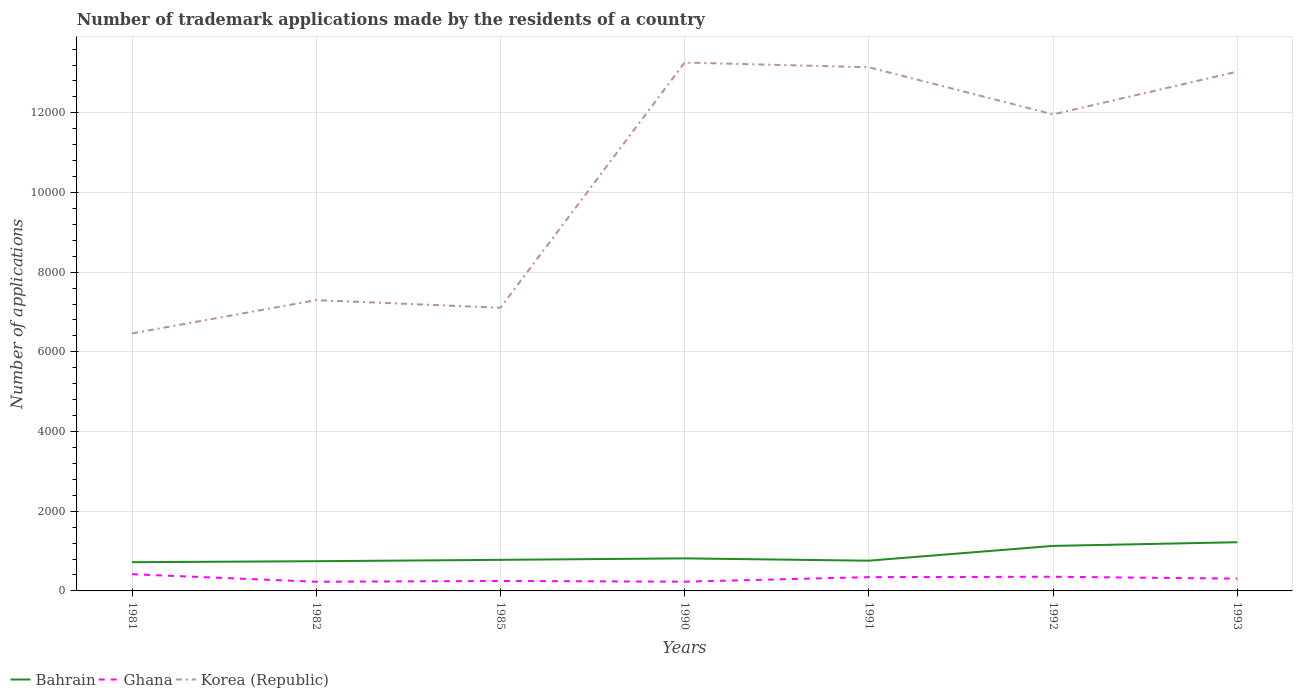Across all years, what is the maximum number of trademark applications made by the residents in Korea (Republic)?
Provide a succinct answer. 6463. In which year was the number of trademark applications made by the residents in Bahrain maximum?
Your answer should be very brief. 1981. What is the total number of trademark applications made by the residents in Bahrain in the graph?
Offer a very short reply. -384. What is the difference between the highest and the second highest number of trademark applications made by the residents in Ghana?
Your answer should be very brief. 189. What is the difference between the highest and the lowest number of trademark applications made by the residents in Ghana?
Your answer should be very brief. 4. Is the number of trademark applications made by the residents in Bahrain strictly greater than the number of trademark applications made by the residents in Ghana over the years?
Give a very brief answer. No. How many years are there in the graph?
Keep it short and to the point. 7. What is the difference between two consecutive major ticks on the Y-axis?
Provide a succinct answer. 2000. Are the values on the major ticks of Y-axis written in scientific E-notation?
Your answer should be very brief. No. How many legend labels are there?
Offer a terse response. 3. How are the legend labels stacked?
Your response must be concise. Horizontal. What is the title of the graph?
Offer a terse response. Number of trademark applications made by the residents of a country. What is the label or title of the Y-axis?
Keep it short and to the point. Number of applications. What is the Number of applications of Bahrain in 1981?
Give a very brief answer. 721. What is the Number of applications of Ghana in 1981?
Offer a very short reply. 419. What is the Number of applications in Korea (Republic) in 1981?
Keep it short and to the point. 6463. What is the Number of applications in Bahrain in 1982?
Your response must be concise. 746. What is the Number of applications of Ghana in 1982?
Make the answer very short. 230. What is the Number of applications of Korea (Republic) in 1982?
Give a very brief answer. 7299. What is the Number of applications of Bahrain in 1985?
Your answer should be very brief. 780. What is the Number of applications of Ghana in 1985?
Provide a short and direct response. 250. What is the Number of applications in Korea (Republic) in 1985?
Offer a terse response. 7107. What is the Number of applications in Bahrain in 1990?
Your answer should be compact. 817. What is the Number of applications of Ghana in 1990?
Your answer should be compact. 232. What is the Number of applications of Korea (Republic) in 1990?
Your answer should be compact. 1.33e+04. What is the Number of applications in Bahrain in 1991?
Your answer should be very brief. 759. What is the Number of applications in Ghana in 1991?
Offer a very short reply. 346. What is the Number of applications in Korea (Republic) in 1991?
Make the answer very short. 1.31e+04. What is the Number of applications in Bahrain in 1992?
Your answer should be very brief. 1130. What is the Number of applications of Ghana in 1992?
Your answer should be very brief. 356. What is the Number of applications in Korea (Republic) in 1992?
Keep it short and to the point. 1.20e+04. What is the Number of applications of Bahrain in 1993?
Keep it short and to the point. 1222. What is the Number of applications of Ghana in 1993?
Your answer should be very brief. 308. What is the Number of applications in Korea (Republic) in 1993?
Provide a succinct answer. 1.30e+04. Across all years, what is the maximum Number of applications in Bahrain?
Offer a very short reply. 1222. Across all years, what is the maximum Number of applications of Ghana?
Your answer should be compact. 419. Across all years, what is the maximum Number of applications in Korea (Republic)?
Your answer should be compact. 1.33e+04. Across all years, what is the minimum Number of applications of Bahrain?
Provide a short and direct response. 721. Across all years, what is the minimum Number of applications in Ghana?
Provide a succinct answer. 230. Across all years, what is the minimum Number of applications of Korea (Republic)?
Ensure brevity in your answer.  6463. What is the total Number of applications of Bahrain in the graph?
Offer a terse response. 6175. What is the total Number of applications of Ghana in the graph?
Keep it short and to the point. 2141. What is the total Number of applications in Korea (Republic) in the graph?
Ensure brevity in your answer.  7.23e+04. What is the difference between the Number of applications of Ghana in 1981 and that in 1982?
Give a very brief answer. 189. What is the difference between the Number of applications of Korea (Republic) in 1981 and that in 1982?
Offer a very short reply. -836. What is the difference between the Number of applications in Bahrain in 1981 and that in 1985?
Make the answer very short. -59. What is the difference between the Number of applications of Ghana in 1981 and that in 1985?
Provide a short and direct response. 169. What is the difference between the Number of applications of Korea (Republic) in 1981 and that in 1985?
Ensure brevity in your answer.  -644. What is the difference between the Number of applications of Bahrain in 1981 and that in 1990?
Keep it short and to the point. -96. What is the difference between the Number of applications in Ghana in 1981 and that in 1990?
Your answer should be compact. 187. What is the difference between the Number of applications of Korea (Republic) in 1981 and that in 1990?
Make the answer very short. -6799. What is the difference between the Number of applications of Bahrain in 1981 and that in 1991?
Offer a terse response. -38. What is the difference between the Number of applications in Ghana in 1981 and that in 1991?
Keep it short and to the point. 73. What is the difference between the Number of applications of Korea (Republic) in 1981 and that in 1991?
Offer a very short reply. -6681. What is the difference between the Number of applications of Bahrain in 1981 and that in 1992?
Offer a terse response. -409. What is the difference between the Number of applications in Ghana in 1981 and that in 1992?
Make the answer very short. 63. What is the difference between the Number of applications in Korea (Republic) in 1981 and that in 1992?
Provide a succinct answer. -5498. What is the difference between the Number of applications in Bahrain in 1981 and that in 1993?
Provide a short and direct response. -501. What is the difference between the Number of applications in Ghana in 1981 and that in 1993?
Your response must be concise. 111. What is the difference between the Number of applications in Korea (Republic) in 1981 and that in 1993?
Ensure brevity in your answer.  -6571. What is the difference between the Number of applications of Bahrain in 1982 and that in 1985?
Your answer should be compact. -34. What is the difference between the Number of applications of Korea (Republic) in 1982 and that in 1985?
Provide a succinct answer. 192. What is the difference between the Number of applications of Bahrain in 1982 and that in 1990?
Offer a very short reply. -71. What is the difference between the Number of applications in Korea (Republic) in 1982 and that in 1990?
Your answer should be compact. -5963. What is the difference between the Number of applications in Bahrain in 1982 and that in 1991?
Provide a succinct answer. -13. What is the difference between the Number of applications in Ghana in 1982 and that in 1991?
Provide a succinct answer. -116. What is the difference between the Number of applications of Korea (Republic) in 1982 and that in 1991?
Offer a terse response. -5845. What is the difference between the Number of applications of Bahrain in 1982 and that in 1992?
Provide a short and direct response. -384. What is the difference between the Number of applications of Ghana in 1982 and that in 1992?
Give a very brief answer. -126. What is the difference between the Number of applications in Korea (Republic) in 1982 and that in 1992?
Ensure brevity in your answer.  -4662. What is the difference between the Number of applications of Bahrain in 1982 and that in 1993?
Offer a terse response. -476. What is the difference between the Number of applications in Ghana in 1982 and that in 1993?
Keep it short and to the point. -78. What is the difference between the Number of applications of Korea (Republic) in 1982 and that in 1993?
Offer a terse response. -5735. What is the difference between the Number of applications of Bahrain in 1985 and that in 1990?
Provide a succinct answer. -37. What is the difference between the Number of applications in Ghana in 1985 and that in 1990?
Ensure brevity in your answer.  18. What is the difference between the Number of applications in Korea (Republic) in 1985 and that in 1990?
Provide a short and direct response. -6155. What is the difference between the Number of applications of Bahrain in 1985 and that in 1991?
Give a very brief answer. 21. What is the difference between the Number of applications in Ghana in 1985 and that in 1991?
Your answer should be compact. -96. What is the difference between the Number of applications of Korea (Republic) in 1985 and that in 1991?
Offer a terse response. -6037. What is the difference between the Number of applications of Bahrain in 1985 and that in 1992?
Offer a very short reply. -350. What is the difference between the Number of applications of Ghana in 1985 and that in 1992?
Provide a short and direct response. -106. What is the difference between the Number of applications in Korea (Republic) in 1985 and that in 1992?
Offer a terse response. -4854. What is the difference between the Number of applications in Bahrain in 1985 and that in 1993?
Give a very brief answer. -442. What is the difference between the Number of applications of Ghana in 1985 and that in 1993?
Make the answer very short. -58. What is the difference between the Number of applications in Korea (Republic) in 1985 and that in 1993?
Make the answer very short. -5927. What is the difference between the Number of applications in Ghana in 1990 and that in 1991?
Make the answer very short. -114. What is the difference between the Number of applications of Korea (Republic) in 1990 and that in 1991?
Your answer should be compact. 118. What is the difference between the Number of applications of Bahrain in 1990 and that in 1992?
Ensure brevity in your answer.  -313. What is the difference between the Number of applications in Ghana in 1990 and that in 1992?
Make the answer very short. -124. What is the difference between the Number of applications of Korea (Republic) in 1990 and that in 1992?
Give a very brief answer. 1301. What is the difference between the Number of applications of Bahrain in 1990 and that in 1993?
Your answer should be compact. -405. What is the difference between the Number of applications of Ghana in 1990 and that in 1993?
Keep it short and to the point. -76. What is the difference between the Number of applications of Korea (Republic) in 1990 and that in 1993?
Make the answer very short. 228. What is the difference between the Number of applications in Bahrain in 1991 and that in 1992?
Offer a very short reply. -371. What is the difference between the Number of applications of Ghana in 1991 and that in 1992?
Make the answer very short. -10. What is the difference between the Number of applications of Korea (Republic) in 1991 and that in 1992?
Offer a terse response. 1183. What is the difference between the Number of applications of Bahrain in 1991 and that in 1993?
Provide a succinct answer. -463. What is the difference between the Number of applications of Ghana in 1991 and that in 1993?
Your answer should be very brief. 38. What is the difference between the Number of applications of Korea (Republic) in 1991 and that in 1993?
Your answer should be compact. 110. What is the difference between the Number of applications in Bahrain in 1992 and that in 1993?
Make the answer very short. -92. What is the difference between the Number of applications of Ghana in 1992 and that in 1993?
Your response must be concise. 48. What is the difference between the Number of applications in Korea (Republic) in 1992 and that in 1993?
Offer a very short reply. -1073. What is the difference between the Number of applications in Bahrain in 1981 and the Number of applications in Ghana in 1982?
Offer a terse response. 491. What is the difference between the Number of applications of Bahrain in 1981 and the Number of applications of Korea (Republic) in 1982?
Your answer should be compact. -6578. What is the difference between the Number of applications of Ghana in 1981 and the Number of applications of Korea (Republic) in 1982?
Provide a succinct answer. -6880. What is the difference between the Number of applications of Bahrain in 1981 and the Number of applications of Ghana in 1985?
Make the answer very short. 471. What is the difference between the Number of applications in Bahrain in 1981 and the Number of applications in Korea (Republic) in 1985?
Offer a terse response. -6386. What is the difference between the Number of applications in Ghana in 1981 and the Number of applications in Korea (Republic) in 1985?
Keep it short and to the point. -6688. What is the difference between the Number of applications of Bahrain in 1981 and the Number of applications of Ghana in 1990?
Provide a succinct answer. 489. What is the difference between the Number of applications of Bahrain in 1981 and the Number of applications of Korea (Republic) in 1990?
Offer a very short reply. -1.25e+04. What is the difference between the Number of applications in Ghana in 1981 and the Number of applications in Korea (Republic) in 1990?
Offer a very short reply. -1.28e+04. What is the difference between the Number of applications of Bahrain in 1981 and the Number of applications of Ghana in 1991?
Your response must be concise. 375. What is the difference between the Number of applications in Bahrain in 1981 and the Number of applications in Korea (Republic) in 1991?
Your response must be concise. -1.24e+04. What is the difference between the Number of applications in Ghana in 1981 and the Number of applications in Korea (Republic) in 1991?
Your response must be concise. -1.27e+04. What is the difference between the Number of applications of Bahrain in 1981 and the Number of applications of Ghana in 1992?
Provide a succinct answer. 365. What is the difference between the Number of applications of Bahrain in 1981 and the Number of applications of Korea (Republic) in 1992?
Provide a short and direct response. -1.12e+04. What is the difference between the Number of applications in Ghana in 1981 and the Number of applications in Korea (Republic) in 1992?
Ensure brevity in your answer.  -1.15e+04. What is the difference between the Number of applications in Bahrain in 1981 and the Number of applications in Ghana in 1993?
Provide a short and direct response. 413. What is the difference between the Number of applications in Bahrain in 1981 and the Number of applications in Korea (Republic) in 1993?
Your answer should be compact. -1.23e+04. What is the difference between the Number of applications of Ghana in 1981 and the Number of applications of Korea (Republic) in 1993?
Keep it short and to the point. -1.26e+04. What is the difference between the Number of applications of Bahrain in 1982 and the Number of applications of Ghana in 1985?
Give a very brief answer. 496. What is the difference between the Number of applications of Bahrain in 1982 and the Number of applications of Korea (Republic) in 1985?
Ensure brevity in your answer.  -6361. What is the difference between the Number of applications of Ghana in 1982 and the Number of applications of Korea (Republic) in 1985?
Make the answer very short. -6877. What is the difference between the Number of applications in Bahrain in 1982 and the Number of applications in Ghana in 1990?
Keep it short and to the point. 514. What is the difference between the Number of applications in Bahrain in 1982 and the Number of applications in Korea (Republic) in 1990?
Make the answer very short. -1.25e+04. What is the difference between the Number of applications of Ghana in 1982 and the Number of applications of Korea (Republic) in 1990?
Your answer should be compact. -1.30e+04. What is the difference between the Number of applications of Bahrain in 1982 and the Number of applications of Ghana in 1991?
Keep it short and to the point. 400. What is the difference between the Number of applications in Bahrain in 1982 and the Number of applications in Korea (Republic) in 1991?
Make the answer very short. -1.24e+04. What is the difference between the Number of applications of Ghana in 1982 and the Number of applications of Korea (Republic) in 1991?
Keep it short and to the point. -1.29e+04. What is the difference between the Number of applications of Bahrain in 1982 and the Number of applications of Ghana in 1992?
Offer a terse response. 390. What is the difference between the Number of applications of Bahrain in 1982 and the Number of applications of Korea (Republic) in 1992?
Ensure brevity in your answer.  -1.12e+04. What is the difference between the Number of applications in Ghana in 1982 and the Number of applications in Korea (Republic) in 1992?
Your answer should be compact. -1.17e+04. What is the difference between the Number of applications of Bahrain in 1982 and the Number of applications of Ghana in 1993?
Ensure brevity in your answer.  438. What is the difference between the Number of applications of Bahrain in 1982 and the Number of applications of Korea (Republic) in 1993?
Offer a terse response. -1.23e+04. What is the difference between the Number of applications of Ghana in 1982 and the Number of applications of Korea (Republic) in 1993?
Ensure brevity in your answer.  -1.28e+04. What is the difference between the Number of applications in Bahrain in 1985 and the Number of applications in Ghana in 1990?
Your response must be concise. 548. What is the difference between the Number of applications of Bahrain in 1985 and the Number of applications of Korea (Republic) in 1990?
Provide a succinct answer. -1.25e+04. What is the difference between the Number of applications in Ghana in 1985 and the Number of applications in Korea (Republic) in 1990?
Your answer should be very brief. -1.30e+04. What is the difference between the Number of applications of Bahrain in 1985 and the Number of applications of Ghana in 1991?
Your answer should be very brief. 434. What is the difference between the Number of applications in Bahrain in 1985 and the Number of applications in Korea (Republic) in 1991?
Provide a short and direct response. -1.24e+04. What is the difference between the Number of applications in Ghana in 1985 and the Number of applications in Korea (Republic) in 1991?
Provide a short and direct response. -1.29e+04. What is the difference between the Number of applications of Bahrain in 1985 and the Number of applications of Ghana in 1992?
Your answer should be very brief. 424. What is the difference between the Number of applications in Bahrain in 1985 and the Number of applications in Korea (Republic) in 1992?
Give a very brief answer. -1.12e+04. What is the difference between the Number of applications of Ghana in 1985 and the Number of applications of Korea (Republic) in 1992?
Give a very brief answer. -1.17e+04. What is the difference between the Number of applications of Bahrain in 1985 and the Number of applications of Ghana in 1993?
Provide a succinct answer. 472. What is the difference between the Number of applications of Bahrain in 1985 and the Number of applications of Korea (Republic) in 1993?
Make the answer very short. -1.23e+04. What is the difference between the Number of applications of Ghana in 1985 and the Number of applications of Korea (Republic) in 1993?
Ensure brevity in your answer.  -1.28e+04. What is the difference between the Number of applications of Bahrain in 1990 and the Number of applications of Ghana in 1991?
Offer a very short reply. 471. What is the difference between the Number of applications of Bahrain in 1990 and the Number of applications of Korea (Republic) in 1991?
Offer a terse response. -1.23e+04. What is the difference between the Number of applications in Ghana in 1990 and the Number of applications in Korea (Republic) in 1991?
Provide a succinct answer. -1.29e+04. What is the difference between the Number of applications in Bahrain in 1990 and the Number of applications in Ghana in 1992?
Your response must be concise. 461. What is the difference between the Number of applications of Bahrain in 1990 and the Number of applications of Korea (Republic) in 1992?
Keep it short and to the point. -1.11e+04. What is the difference between the Number of applications of Ghana in 1990 and the Number of applications of Korea (Republic) in 1992?
Your response must be concise. -1.17e+04. What is the difference between the Number of applications in Bahrain in 1990 and the Number of applications in Ghana in 1993?
Your response must be concise. 509. What is the difference between the Number of applications of Bahrain in 1990 and the Number of applications of Korea (Republic) in 1993?
Offer a very short reply. -1.22e+04. What is the difference between the Number of applications of Ghana in 1990 and the Number of applications of Korea (Republic) in 1993?
Offer a very short reply. -1.28e+04. What is the difference between the Number of applications of Bahrain in 1991 and the Number of applications of Ghana in 1992?
Ensure brevity in your answer.  403. What is the difference between the Number of applications of Bahrain in 1991 and the Number of applications of Korea (Republic) in 1992?
Give a very brief answer. -1.12e+04. What is the difference between the Number of applications in Ghana in 1991 and the Number of applications in Korea (Republic) in 1992?
Provide a short and direct response. -1.16e+04. What is the difference between the Number of applications of Bahrain in 1991 and the Number of applications of Ghana in 1993?
Your response must be concise. 451. What is the difference between the Number of applications in Bahrain in 1991 and the Number of applications in Korea (Republic) in 1993?
Make the answer very short. -1.23e+04. What is the difference between the Number of applications in Ghana in 1991 and the Number of applications in Korea (Republic) in 1993?
Keep it short and to the point. -1.27e+04. What is the difference between the Number of applications of Bahrain in 1992 and the Number of applications of Ghana in 1993?
Offer a very short reply. 822. What is the difference between the Number of applications of Bahrain in 1992 and the Number of applications of Korea (Republic) in 1993?
Give a very brief answer. -1.19e+04. What is the difference between the Number of applications in Ghana in 1992 and the Number of applications in Korea (Republic) in 1993?
Give a very brief answer. -1.27e+04. What is the average Number of applications in Bahrain per year?
Offer a terse response. 882.14. What is the average Number of applications in Ghana per year?
Your response must be concise. 305.86. What is the average Number of applications of Korea (Republic) per year?
Ensure brevity in your answer.  1.03e+04. In the year 1981, what is the difference between the Number of applications of Bahrain and Number of applications of Ghana?
Offer a very short reply. 302. In the year 1981, what is the difference between the Number of applications of Bahrain and Number of applications of Korea (Republic)?
Provide a succinct answer. -5742. In the year 1981, what is the difference between the Number of applications in Ghana and Number of applications in Korea (Republic)?
Offer a terse response. -6044. In the year 1982, what is the difference between the Number of applications in Bahrain and Number of applications in Ghana?
Your response must be concise. 516. In the year 1982, what is the difference between the Number of applications in Bahrain and Number of applications in Korea (Republic)?
Make the answer very short. -6553. In the year 1982, what is the difference between the Number of applications of Ghana and Number of applications of Korea (Republic)?
Your response must be concise. -7069. In the year 1985, what is the difference between the Number of applications of Bahrain and Number of applications of Ghana?
Offer a terse response. 530. In the year 1985, what is the difference between the Number of applications in Bahrain and Number of applications in Korea (Republic)?
Your answer should be compact. -6327. In the year 1985, what is the difference between the Number of applications of Ghana and Number of applications of Korea (Republic)?
Offer a very short reply. -6857. In the year 1990, what is the difference between the Number of applications in Bahrain and Number of applications in Ghana?
Ensure brevity in your answer.  585. In the year 1990, what is the difference between the Number of applications of Bahrain and Number of applications of Korea (Republic)?
Your answer should be very brief. -1.24e+04. In the year 1990, what is the difference between the Number of applications of Ghana and Number of applications of Korea (Republic)?
Offer a terse response. -1.30e+04. In the year 1991, what is the difference between the Number of applications in Bahrain and Number of applications in Ghana?
Provide a succinct answer. 413. In the year 1991, what is the difference between the Number of applications in Bahrain and Number of applications in Korea (Republic)?
Your answer should be very brief. -1.24e+04. In the year 1991, what is the difference between the Number of applications of Ghana and Number of applications of Korea (Republic)?
Your response must be concise. -1.28e+04. In the year 1992, what is the difference between the Number of applications in Bahrain and Number of applications in Ghana?
Your answer should be very brief. 774. In the year 1992, what is the difference between the Number of applications in Bahrain and Number of applications in Korea (Republic)?
Ensure brevity in your answer.  -1.08e+04. In the year 1992, what is the difference between the Number of applications in Ghana and Number of applications in Korea (Republic)?
Give a very brief answer. -1.16e+04. In the year 1993, what is the difference between the Number of applications in Bahrain and Number of applications in Ghana?
Make the answer very short. 914. In the year 1993, what is the difference between the Number of applications of Bahrain and Number of applications of Korea (Republic)?
Your response must be concise. -1.18e+04. In the year 1993, what is the difference between the Number of applications in Ghana and Number of applications in Korea (Republic)?
Your answer should be very brief. -1.27e+04. What is the ratio of the Number of applications of Bahrain in 1981 to that in 1982?
Offer a very short reply. 0.97. What is the ratio of the Number of applications in Ghana in 1981 to that in 1982?
Offer a terse response. 1.82. What is the ratio of the Number of applications of Korea (Republic) in 1981 to that in 1982?
Keep it short and to the point. 0.89. What is the ratio of the Number of applications of Bahrain in 1981 to that in 1985?
Provide a succinct answer. 0.92. What is the ratio of the Number of applications of Ghana in 1981 to that in 1985?
Your answer should be very brief. 1.68. What is the ratio of the Number of applications in Korea (Republic) in 1981 to that in 1985?
Give a very brief answer. 0.91. What is the ratio of the Number of applications in Bahrain in 1981 to that in 1990?
Your response must be concise. 0.88. What is the ratio of the Number of applications in Ghana in 1981 to that in 1990?
Your answer should be compact. 1.81. What is the ratio of the Number of applications of Korea (Republic) in 1981 to that in 1990?
Provide a short and direct response. 0.49. What is the ratio of the Number of applications in Bahrain in 1981 to that in 1991?
Offer a very short reply. 0.95. What is the ratio of the Number of applications in Ghana in 1981 to that in 1991?
Your answer should be very brief. 1.21. What is the ratio of the Number of applications in Korea (Republic) in 1981 to that in 1991?
Make the answer very short. 0.49. What is the ratio of the Number of applications of Bahrain in 1981 to that in 1992?
Offer a very short reply. 0.64. What is the ratio of the Number of applications of Ghana in 1981 to that in 1992?
Provide a succinct answer. 1.18. What is the ratio of the Number of applications in Korea (Republic) in 1981 to that in 1992?
Offer a terse response. 0.54. What is the ratio of the Number of applications in Bahrain in 1981 to that in 1993?
Offer a terse response. 0.59. What is the ratio of the Number of applications of Ghana in 1981 to that in 1993?
Give a very brief answer. 1.36. What is the ratio of the Number of applications in Korea (Republic) in 1981 to that in 1993?
Provide a short and direct response. 0.5. What is the ratio of the Number of applications in Bahrain in 1982 to that in 1985?
Ensure brevity in your answer.  0.96. What is the ratio of the Number of applications in Bahrain in 1982 to that in 1990?
Ensure brevity in your answer.  0.91. What is the ratio of the Number of applications in Ghana in 1982 to that in 1990?
Make the answer very short. 0.99. What is the ratio of the Number of applications of Korea (Republic) in 1982 to that in 1990?
Your answer should be very brief. 0.55. What is the ratio of the Number of applications in Bahrain in 1982 to that in 1991?
Give a very brief answer. 0.98. What is the ratio of the Number of applications in Ghana in 1982 to that in 1991?
Keep it short and to the point. 0.66. What is the ratio of the Number of applications of Korea (Republic) in 1982 to that in 1991?
Keep it short and to the point. 0.56. What is the ratio of the Number of applications in Bahrain in 1982 to that in 1992?
Provide a succinct answer. 0.66. What is the ratio of the Number of applications of Ghana in 1982 to that in 1992?
Ensure brevity in your answer.  0.65. What is the ratio of the Number of applications of Korea (Republic) in 1982 to that in 1992?
Your answer should be very brief. 0.61. What is the ratio of the Number of applications of Bahrain in 1982 to that in 1993?
Your answer should be very brief. 0.61. What is the ratio of the Number of applications in Ghana in 1982 to that in 1993?
Your answer should be compact. 0.75. What is the ratio of the Number of applications of Korea (Republic) in 1982 to that in 1993?
Your answer should be very brief. 0.56. What is the ratio of the Number of applications of Bahrain in 1985 to that in 1990?
Your response must be concise. 0.95. What is the ratio of the Number of applications in Ghana in 1985 to that in 1990?
Your response must be concise. 1.08. What is the ratio of the Number of applications in Korea (Republic) in 1985 to that in 1990?
Offer a very short reply. 0.54. What is the ratio of the Number of applications in Bahrain in 1985 to that in 1991?
Give a very brief answer. 1.03. What is the ratio of the Number of applications in Ghana in 1985 to that in 1991?
Keep it short and to the point. 0.72. What is the ratio of the Number of applications of Korea (Republic) in 1985 to that in 1991?
Your answer should be very brief. 0.54. What is the ratio of the Number of applications of Bahrain in 1985 to that in 1992?
Your answer should be very brief. 0.69. What is the ratio of the Number of applications of Ghana in 1985 to that in 1992?
Provide a succinct answer. 0.7. What is the ratio of the Number of applications of Korea (Republic) in 1985 to that in 1992?
Give a very brief answer. 0.59. What is the ratio of the Number of applications in Bahrain in 1985 to that in 1993?
Give a very brief answer. 0.64. What is the ratio of the Number of applications of Ghana in 1985 to that in 1993?
Offer a very short reply. 0.81. What is the ratio of the Number of applications in Korea (Republic) in 1985 to that in 1993?
Offer a very short reply. 0.55. What is the ratio of the Number of applications of Bahrain in 1990 to that in 1991?
Give a very brief answer. 1.08. What is the ratio of the Number of applications of Ghana in 1990 to that in 1991?
Offer a very short reply. 0.67. What is the ratio of the Number of applications of Bahrain in 1990 to that in 1992?
Offer a terse response. 0.72. What is the ratio of the Number of applications of Ghana in 1990 to that in 1992?
Your response must be concise. 0.65. What is the ratio of the Number of applications of Korea (Republic) in 1990 to that in 1992?
Make the answer very short. 1.11. What is the ratio of the Number of applications in Bahrain in 1990 to that in 1993?
Offer a terse response. 0.67. What is the ratio of the Number of applications in Ghana in 1990 to that in 1993?
Offer a very short reply. 0.75. What is the ratio of the Number of applications in Korea (Republic) in 1990 to that in 1993?
Provide a short and direct response. 1.02. What is the ratio of the Number of applications of Bahrain in 1991 to that in 1992?
Offer a very short reply. 0.67. What is the ratio of the Number of applications in Ghana in 1991 to that in 1992?
Your answer should be compact. 0.97. What is the ratio of the Number of applications of Korea (Republic) in 1991 to that in 1992?
Give a very brief answer. 1.1. What is the ratio of the Number of applications in Bahrain in 1991 to that in 1993?
Offer a terse response. 0.62. What is the ratio of the Number of applications of Ghana in 1991 to that in 1993?
Provide a succinct answer. 1.12. What is the ratio of the Number of applications of Korea (Republic) in 1991 to that in 1993?
Your response must be concise. 1.01. What is the ratio of the Number of applications of Bahrain in 1992 to that in 1993?
Keep it short and to the point. 0.92. What is the ratio of the Number of applications in Ghana in 1992 to that in 1993?
Provide a short and direct response. 1.16. What is the ratio of the Number of applications in Korea (Republic) in 1992 to that in 1993?
Your answer should be very brief. 0.92. What is the difference between the highest and the second highest Number of applications of Bahrain?
Ensure brevity in your answer.  92. What is the difference between the highest and the second highest Number of applications of Korea (Republic)?
Ensure brevity in your answer.  118. What is the difference between the highest and the lowest Number of applications in Bahrain?
Give a very brief answer. 501. What is the difference between the highest and the lowest Number of applications in Ghana?
Offer a very short reply. 189. What is the difference between the highest and the lowest Number of applications in Korea (Republic)?
Offer a terse response. 6799. 